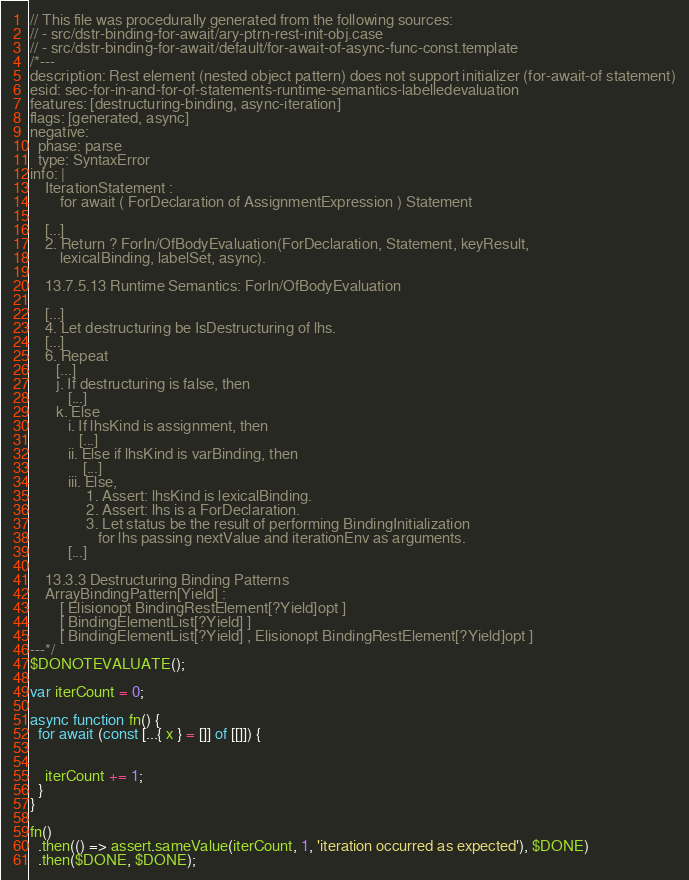Convert code to text. <code><loc_0><loc_0><loc_500><loc_500><_JavaScript_>// This file was procedurally generated from the following sources:
// - src/dstr-binding-for-await/ary-ptrn-rest-init-obj.case
// - src/dstr-binding-for-await/default/for-await-of-async-func-const.template
/*---
description: Rest element (nested object pattern) does not support initializer (for-await-of statement)
esid: sec-for-in-and-for-of-statements-runtime-semantics-labelledevaluation
features: [destructuring-binding, async-iteration]
flags: [generated, async]
negative:
  phase: parse
  type: SyntaxError
info: |
    IterationStatement :
        for await ( ForDeclaration of AssignmentExpression ) Statement

    [...]
    2. Return ? ForIn/OfBodyEvaluation(ForDeclaration, Statement, keyResult,
        lexicalBinding, labelSet, async).

    13.7.5.13 Runtime Semantics: ForIn/OfBodyEvaluation

    [...]
    4. Let destructuring be IsDestructuring of lhs.
    [...]
    6. Repeat
       [...]
       j. If destructuring is false, then
          [...]
       k. Else
          i. If lhsKind is assignment, then
             [...]
          ii. Else if lhsKind is varBinding, then
              [...]
          iii. Else,
               1. Assert: lhsKind is lexicalBinding.
               2. Assert: lhs is a ForDeclaration.
               3. Let status be the result of performing BindingInitialization
                  for lhs passing nextValue and iterationEnv as arguments.
          [...]

    13.3.3 Destructuring Binding Patterns
    ArrayBindingPattern[Yield] :
        [ Elisionopt BindingRestElement[?Yield]opt ]
        [ BindingElementList[?Yield] ]
        [ BindingElementList[?Yield] , Elisionopt BindingRestElement[?Yield]opt ]
---*/
$DONOTEVALUATE();

var iterCount = 0;

async function fn() {
  for await (const [...{ x } = []] of [[]]) {
    

    iterCount += 1;
  }
}

fn()
  .then(() => assert.sameValue(iterCount, 1, 'iteration occurred as expected'), $DONE)
  .then($DONE, $DONE);
</code> 